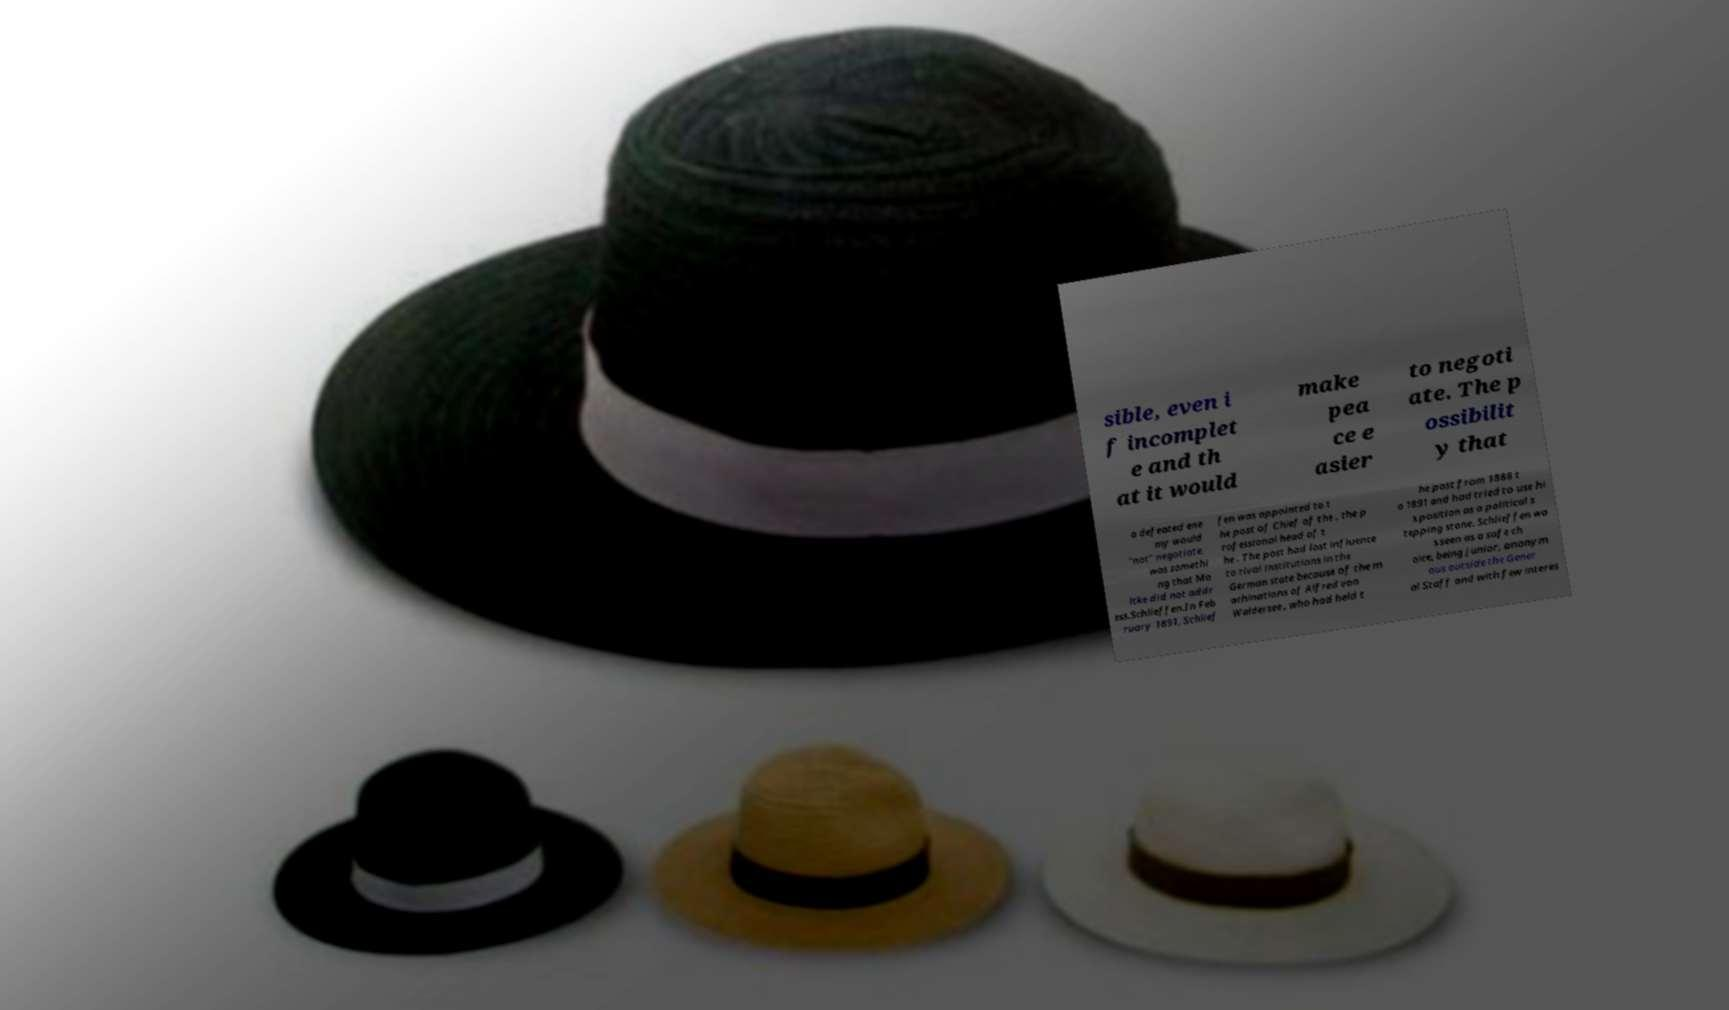For documentation purposes, I need the text within this image transcribed. Could you provide that? sible, even i f incomplet e and th at it would make pea ce e asier to negoti ate. The p ossibilit y that a defeated ene my would "not" negotiate, was somethi ng that Mo ltke did not addr ess.Schlieffen.In Feb ruary 1891, Schlief fen was appointed to t he post of Chief of the , the p rofessional head of t he . The post had lost influence to rival institutions in the German state because of the m achinations of Alfred von Waldersee , who had held t he post from 1888 t o 1891 and had tried to use hi s position as a political s tepping stone. Schlieffen wa s seen as a safe ch oice, being junior, anonym ous outside the Gener al Staff and with few interes 